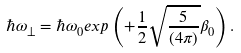Convert formula to latex. <formula><loc_0><loc_0><loc_500><loc_500>\hbar { \omega } _ { \bot } = \hbar { \omega } _ { 0 } e x p \left ( + \frac { 1 } { 2 } \sqrt { \frac { 5 } { ( 4 \pi ) } } \beta _ { 0 } \right ) .</formula> 